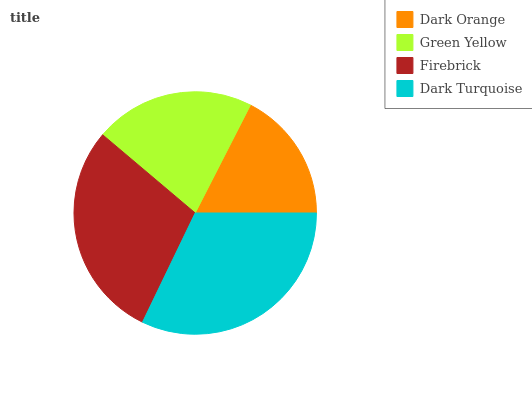Is Dark Orange the minimum?
Answer yes or no. Yes. Is Dark Turquoise the maximum?
Answer yes or no. Yes. Is Green Yellow the minimum?
Answer yes or no. No. Is Green Yellow the maximum?
Answer yes or no. No. Is Green Yellow greater than Dark Orange?
Answer yes or no. Yes. Is Dark Orange less than Green Yellow?
Answer yes or no. Yes. Is Dark Orange greater than Green Yellow?
Answer yes or no. No. Is Green Yellow less than Dark Orange?
Answer yes or no. No. Is Firebrick the high median?
Answer yes or no. Yes. Is Green Yellow the low median?
Answer yes or no. Yes. Is Green Yellow the high median?
Answer yes or no. No. Is Firebrick the low median?
Answer yes or no. No. 